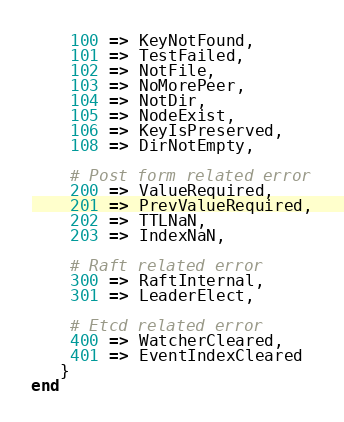Convert code to text. <code><loc_0><loc_0><loc_500><loc_500><_Crystal_>    100 => KeyNotFound,
    101 => TestFailed,
    102 => NotFile,
    103 => NoMorePeer,
    104 => NotDir,
    105 => NodeExist,
    106 => KeyIsPreserved,
    108 => DirNotEmpty,

    # Post form related error
    200 => ValueRequired,
    201 => PrevValueRequired,
    202 => TTLNaN,
    203 => IndexNaN,

    # Raft related error
    300 => RaftInternal,
    301 => LeaderElect,

    # Etcd related error
    400 => WatcherCleared,
    401 => EventIndexCleared
   }
end
</code> 